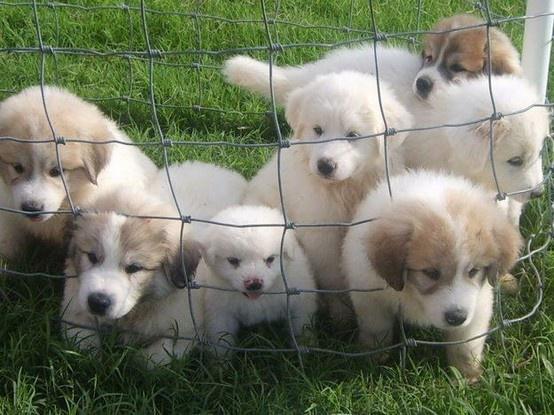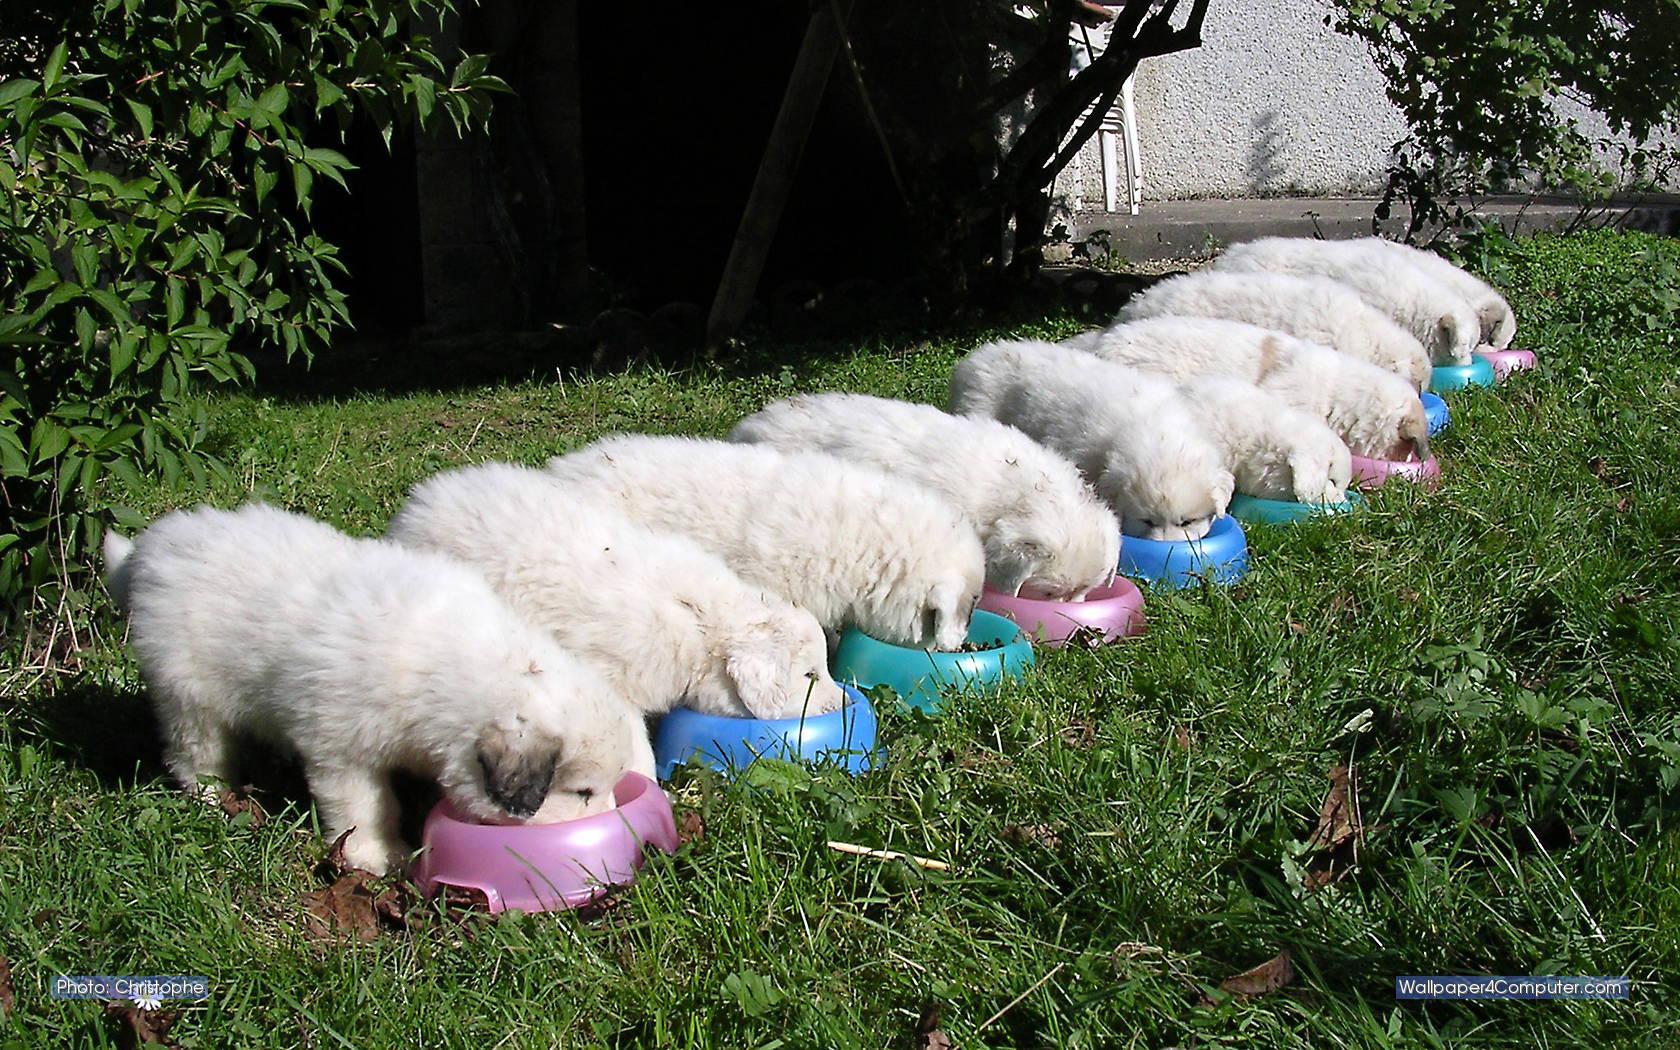The first image is the image on the left, the second image is the image on the right. Examine the images to the left and right. Is the description "At least one of the images is of two dogs." accurate? Answer yes or no. No. The first image is the image on the left, the second image is the image on the right. Examine the images to the left and right. Is the description "In at least one image there are exactly two dogs." accurate? Answer yes or no. No. 